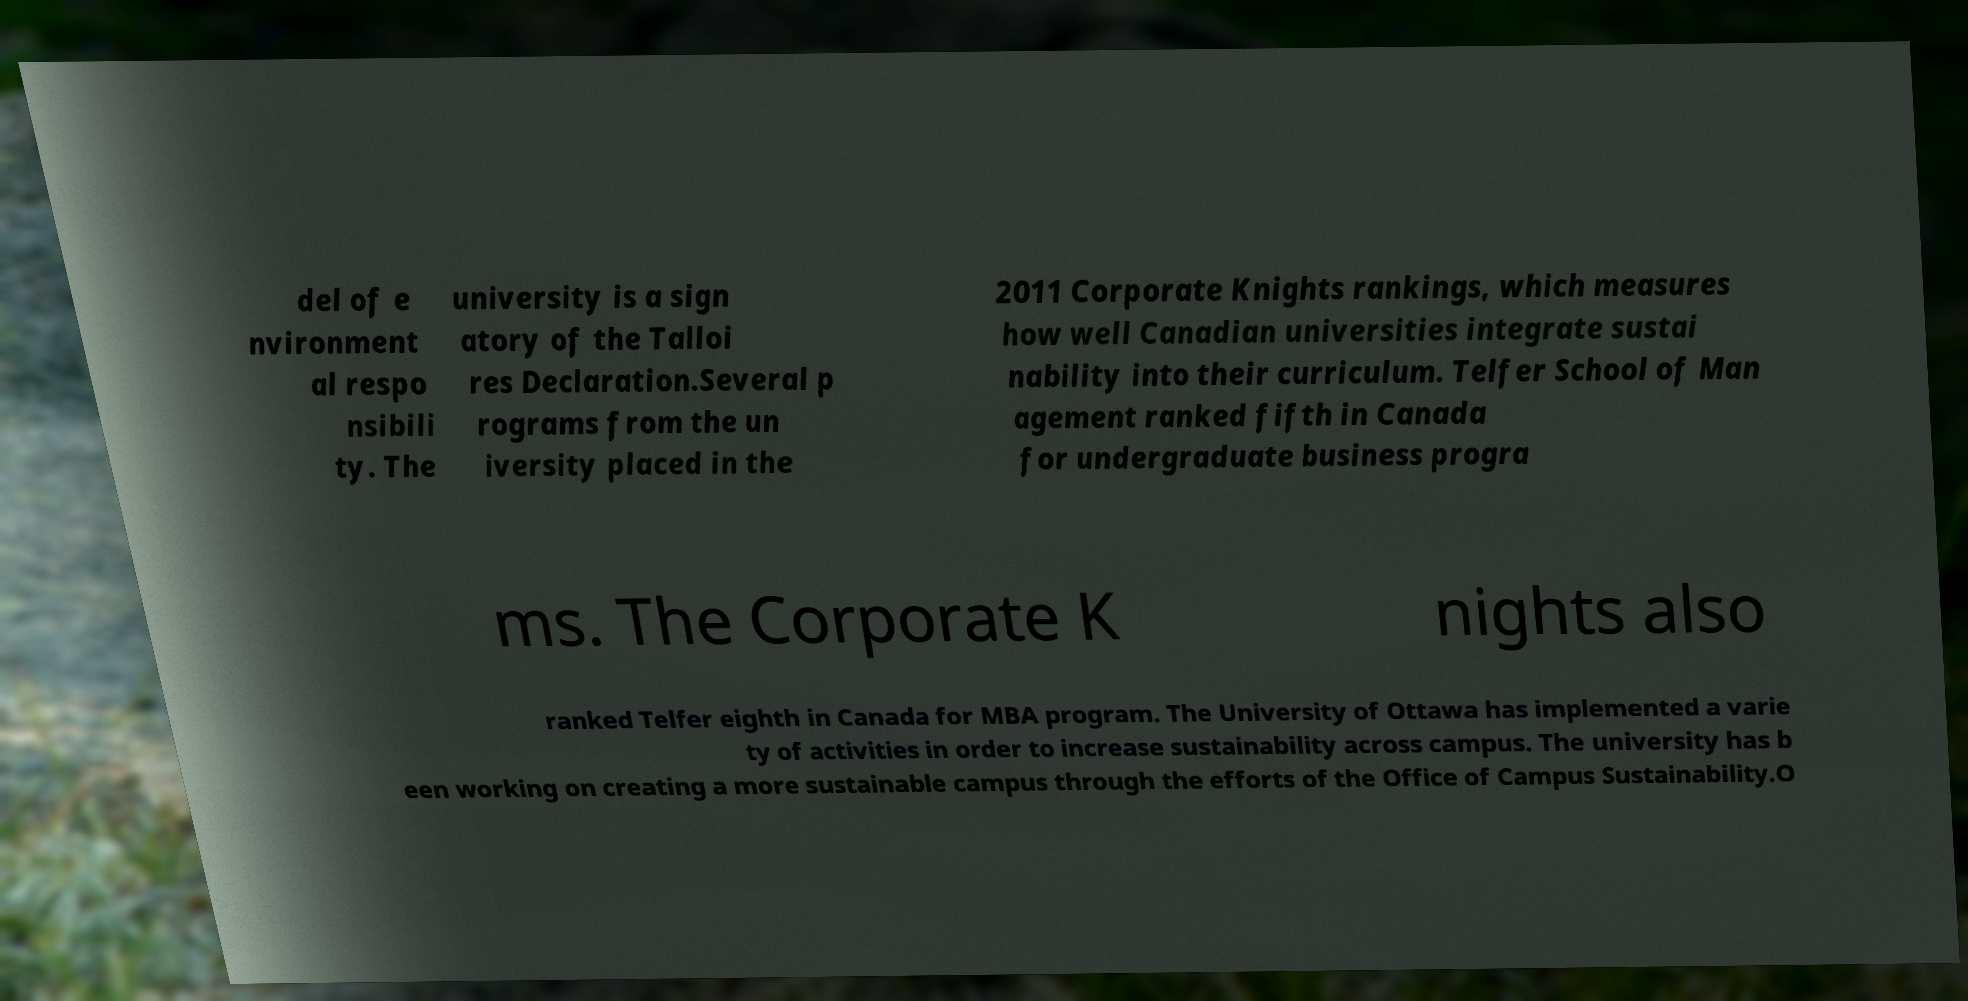Could you assist in decoding the text presented in this image and type it out clearly? del of e nvironment al respo nsibili ty. The university is a sign atory of the Talloi res Declaration.Several p rograms from the un iversity placed in the 2011 Corporate Knights rankings, which measures how well Canadian universities integrate sustai nability into their curriculum. Telfer School of Man agement ranked fifth in Canada for undergraduate business progra ms. The Corporate K nights also ranked Telfer eighth in Canada for MBA program. The University of Ottawa has implemented a varie ty of activities in order to increase sustainability across campus. The university has b een working on creating a more sustainable campus through the efforts of the Office of Campus Sustainability.O 